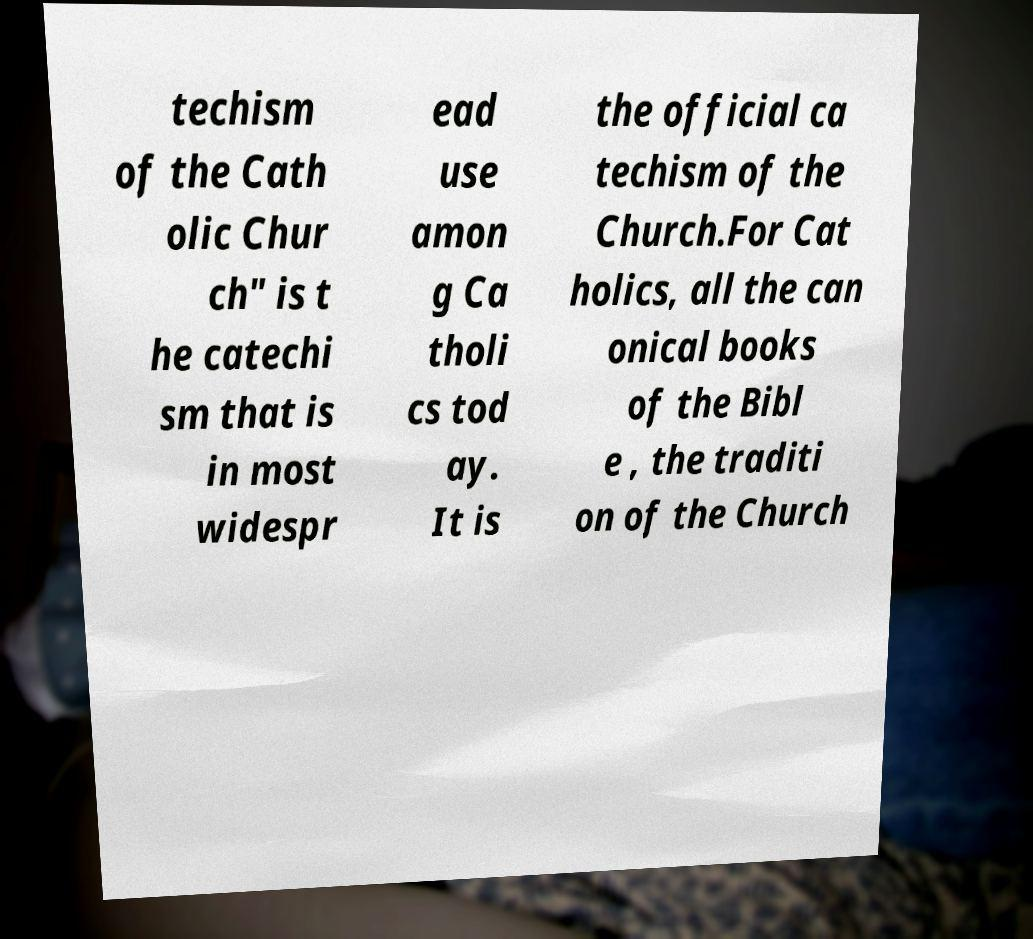Could you assist in decoding the text presented in this image and type it out clearly? techism of the Cath olic Chur ch" is t he catechi sm that is in most widespr ead use amon g Ca tholi cs tod ay. It is the official ca techism of the Church.For Cat holics, all the can onical books of the Bibl e , the traditi on of the Church 